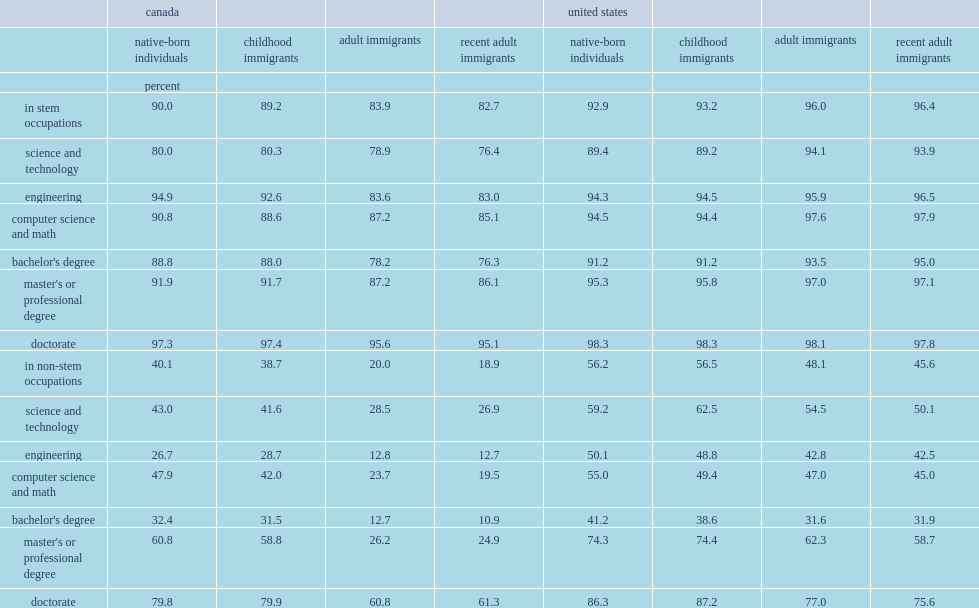In canada, how many percent found adult immigrants in jobs requiring a university degree? 83.9. In the united states, how many percent found adult immigrants in jobs requiring a university degree? 96.0. In canada, how many percent found a job requiring a university degree? 20.0. In canada, how many percent found a job requiring a university degree of the canadian-born population? 40.1. In the united states, how many percent found a job requiring a university degree among adult immigrants? 48.1. In the united states, how many percent found a job requiring a university degree of the canadian-born population among the american-born population? 56.2. Immigrants with an engineering degree who could not find a stem job had particularly poor outcomes in canada, how many percent found a job requiring a university degree? 12.8. Immigrants with an engineering degree who could not find a stem job, how many percent found a job requiring a university degree in the united states? 42.8. 